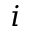Convert formula to latex. <formula><loc_0><loc_0><loc_500><loc_500>i</formula> 